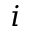Convert formula to latex. <formula><loc_0><loc_0><loc_500><loc_500>i</formula> 